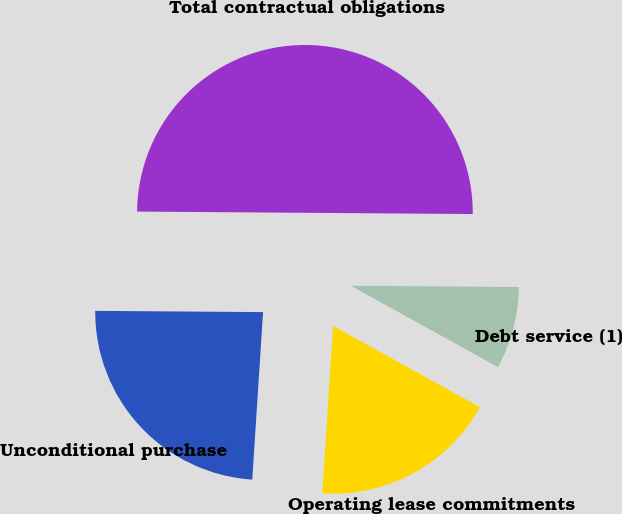<chart> <loc_0><loc_0><loc_500><loc_500><pie_chart><fcel>Debt service (1)<fcel>Operating lease commitments<fcel>Unconditional purchase<fcel>Total contractual obligations<nl><fcel>7.93%<fcel>17.98%<fcel>24.09%<fcel>50.0%<nl></chart> 